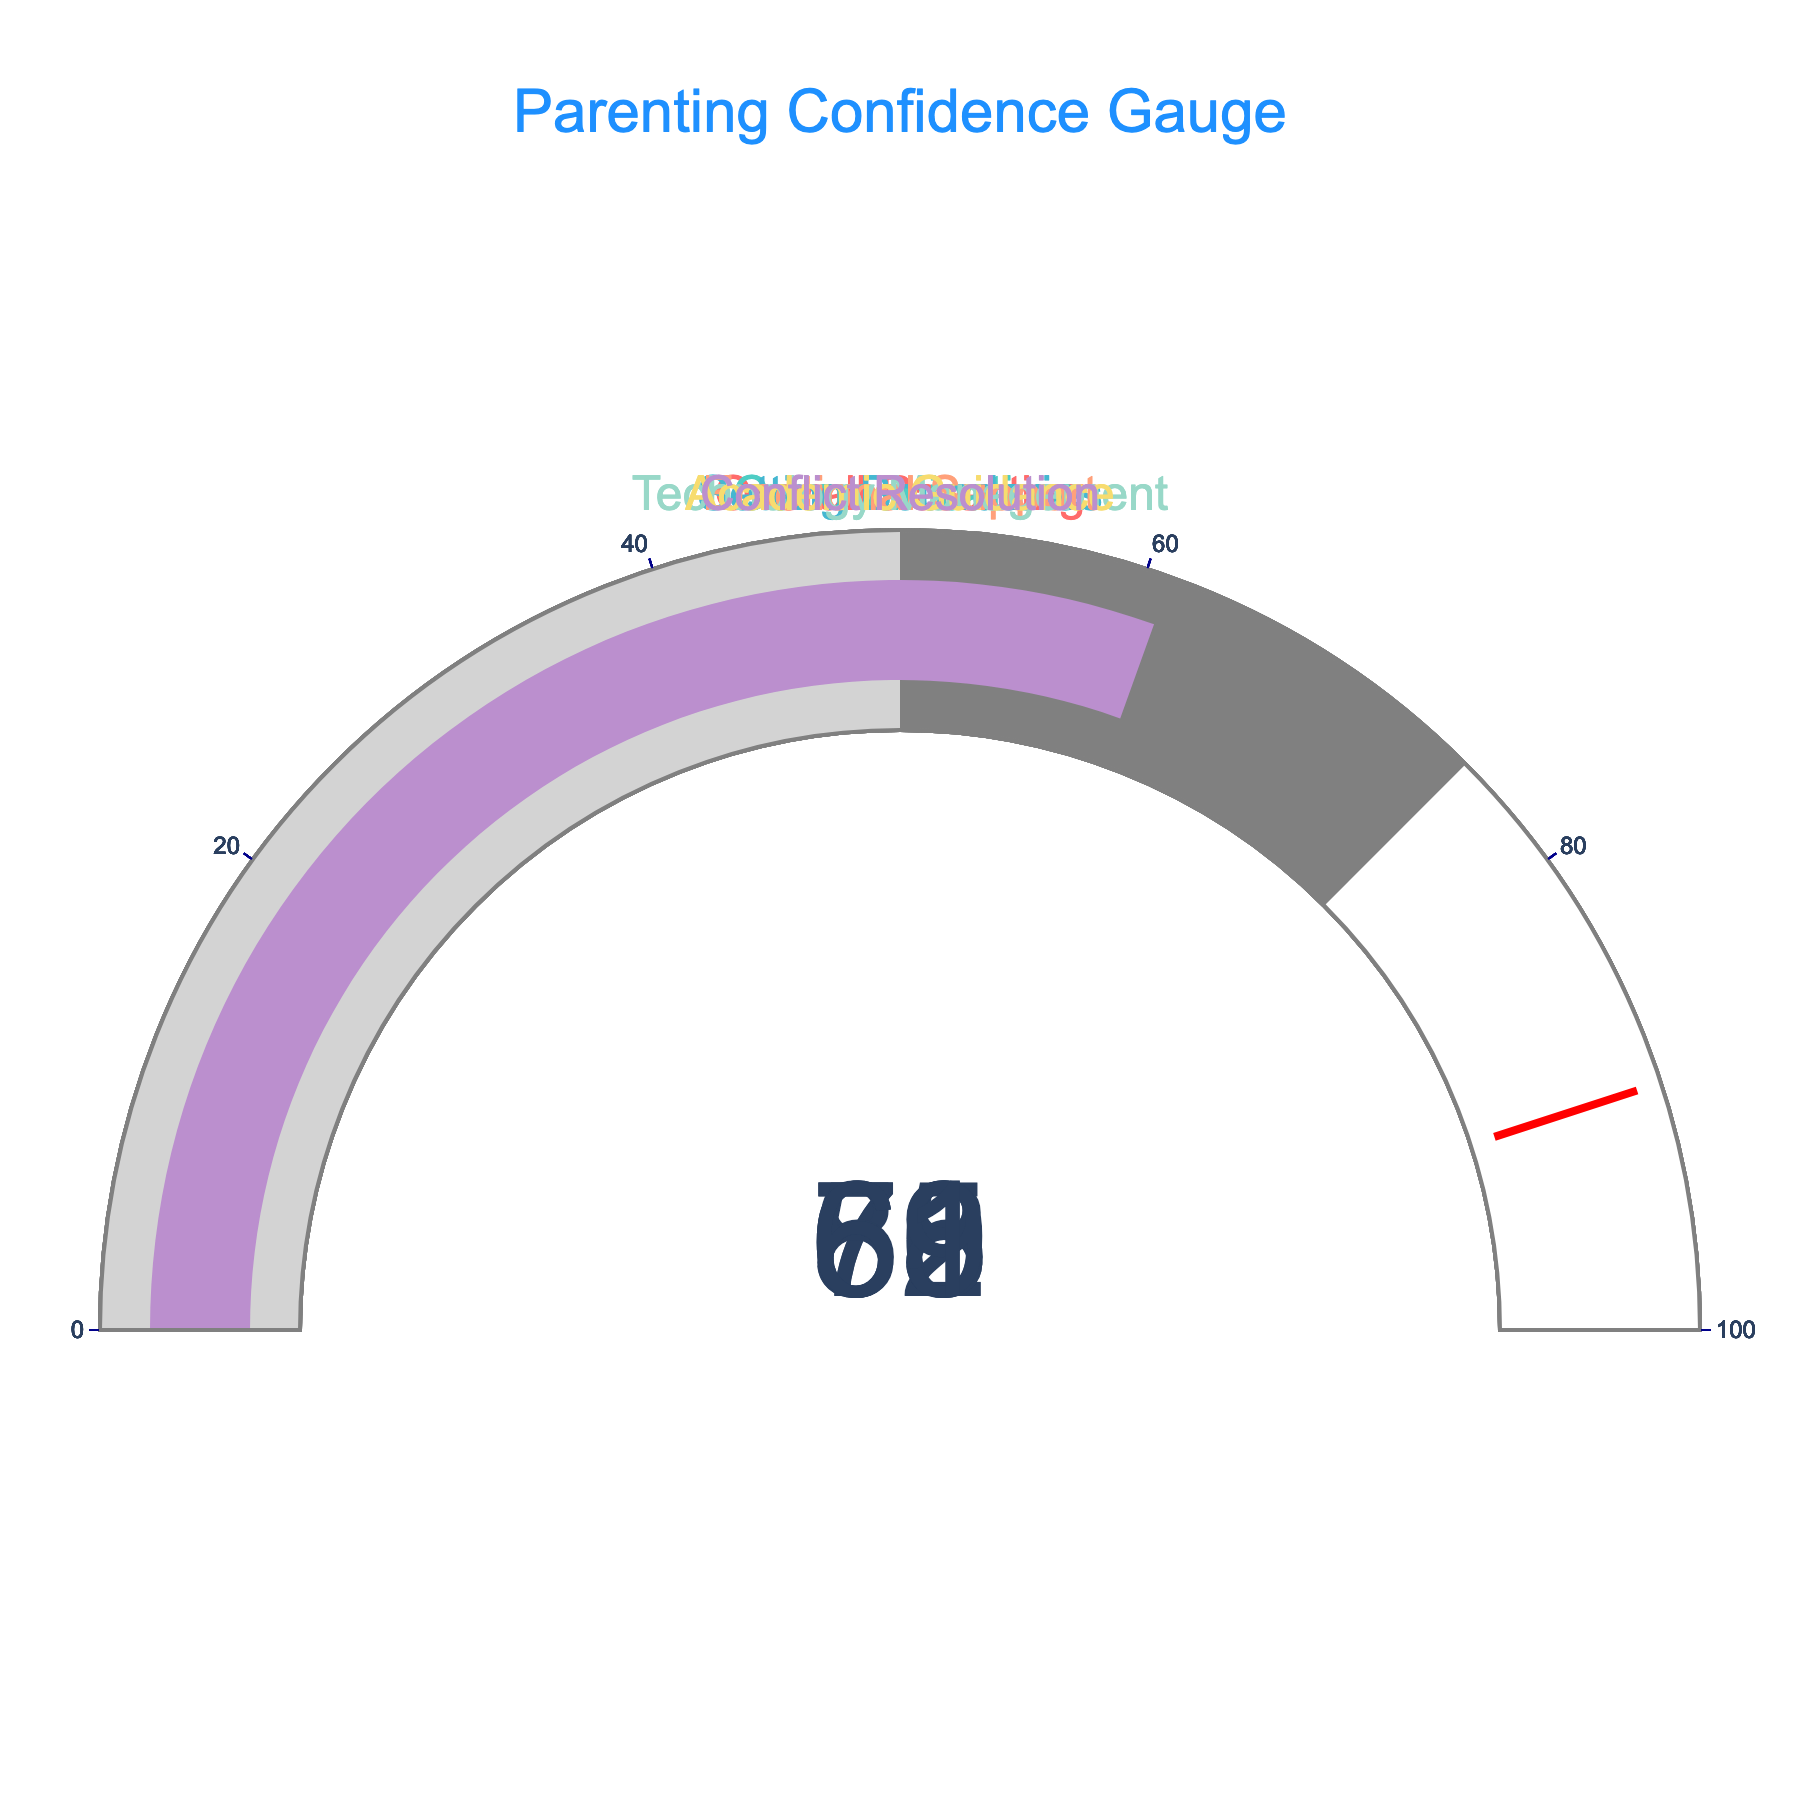What is the confidence percentage for academic guidance? The gauge for academic guidance shows a number indicating the confidence percentage.
Answer: 69 Which area has the highest confidence percentage? By examining all the gauges and identifying the highest number, we find that emotional support has the highest confidence percentage.
Answer: Emotional Support What is the average confidence percentage across all areas? Sum the confidence percentages of all categories (72 + 65 + 78 + 80 + 58 + 69 + 61) = 483 and then divide by the number of categories, which is 7. So, the average is 483/7 ≈ 69
Answer: 69 What is the difference in confidence percentage between communication and technology management? Subtract the confidence percentage of technology management (58) from communication (65).
Answer: 7 Which area has a lower confidence percentage, setting boundaries or conflict resolution? By comparing the confidence percentages for setting boundaries (78) and conflict resolution (61), we see that conflict resolution is lower.
Answer: Conflict Resolution Which areas have a confidence percentage above 70%? Identify all the gauges with a number greater than 70. These areas are overall parenting (72), setting boundaries (78), and emotional support (80).
Answer: Overall Parenting, Setting Boundaries, Emotional Support How much higher is the confidence percentage for emotional support compared to technology management? Subtract the confidence percentage of technology management (58) from emotional support (80).
Answer: 22 What's the median confidence percentage of the categories? Arrange the categories in ascending order of their confidence percentages (58, 61, 65, 69, 72, 78, 80). The median percentage is the middle value, which is 69.
Answer: 69 Which category has the least confidence percentage? By examining the gauges, we see that technology management has the lowest confidence percentage.
Answer: Technology Management How many categories have a confidence percentage below 70? Count the gauges with a confidence number below 70: Communication (65), Technology Management (58), Academic Guidance (69), Conflict Resolution (61). There are four such categories.
Answer: 4 